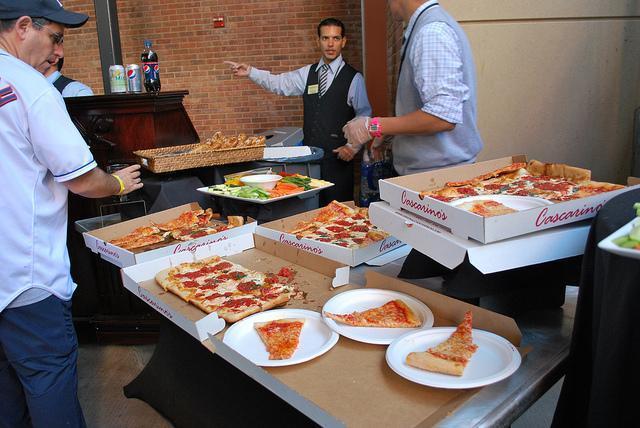How many pizzas are in the picture?
Give a very brief answer. 3. How many people are in the photo?
Give a very brief answer. 3. 